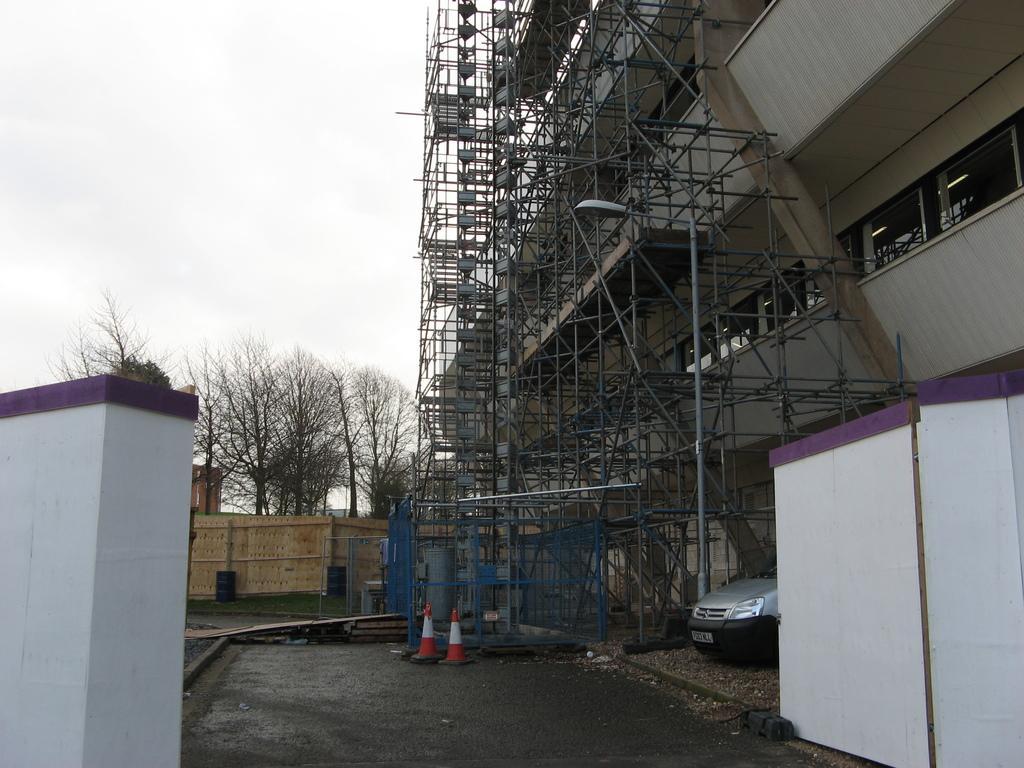Could you give a brief overview of what you see in this image? Here in this picture on the right side we can see a building present and we can see it is under construction, as we can see poles present and we can also see light posts present and on the ground we can see a car present and we can see some walls present and we can also see trees present behind the wall and we can see the sky is cloudy. 